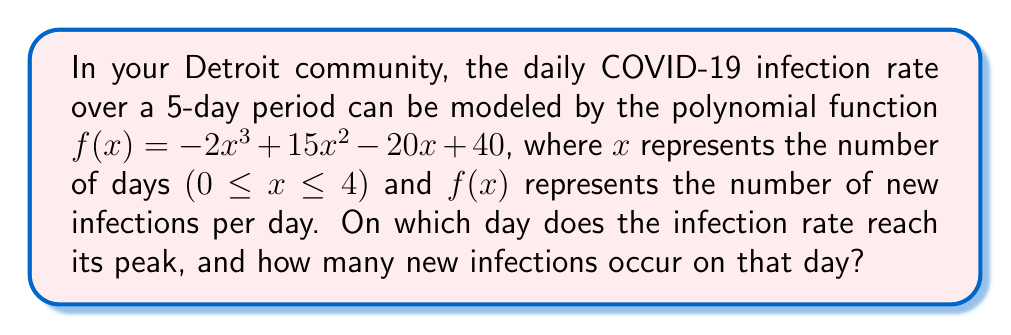Solve this math problem. To solve this problem, we need to follow these steps:

1) The peak of the infection rate occurs at the maximum point of the function $f(x)$.

2) To find the maximum point, we need to find where the derivative $f'(x)$ equals zero.

3) The derivative of $f(x)$ is:
   $f'(x) = -6x^2 + 30x - 20$

4) Set $f'(x) = 0$ and solve for $x$:
   $-6x^2 + 30x - 20 = 0$

5) This is a quadratic equation. We can solve it using the quadratic formula:
   $x = \frac{-b \pm \sqrt{b^2 - 4ac}}{2a}$

   Where $a = -6$, $b = 30$, and $c = -20$

6) Plugging in these values:
   $x = \frac{-30 \pm \sqrt{30^2 - 4(-6)(-20)}}{2(-6)}$
   $= \frac{-30 \pm \sqrt{900 - 480}}{-12}$
   $= \frac{-30 \pm \sqrt{420}}{-12}$
   $= \frac{-30 \pm 20.494}{-12}$

7) This gives us two solutions:
   $x_1 = \frac{-30 + 20.494}{-12} \approx 0.792$
   $x_2 = \frac{-30 - 20.494}{-12} \approx 4.208$

8) Since we're only considering 0 ≤ x ≤ 4, the maximum occurs at x ≈ 0.792, which is closest to day 1.

9) To find the number of infections on this day, we plug x = 1 into our original function:
   $f(1) = -2(1)^3 + 15(1)^2 - 20(1) + 40 = 33$

Therefore, the infection rate peaks on day 1 with 33 new infections.
Answer: Day 1, 33 infections 